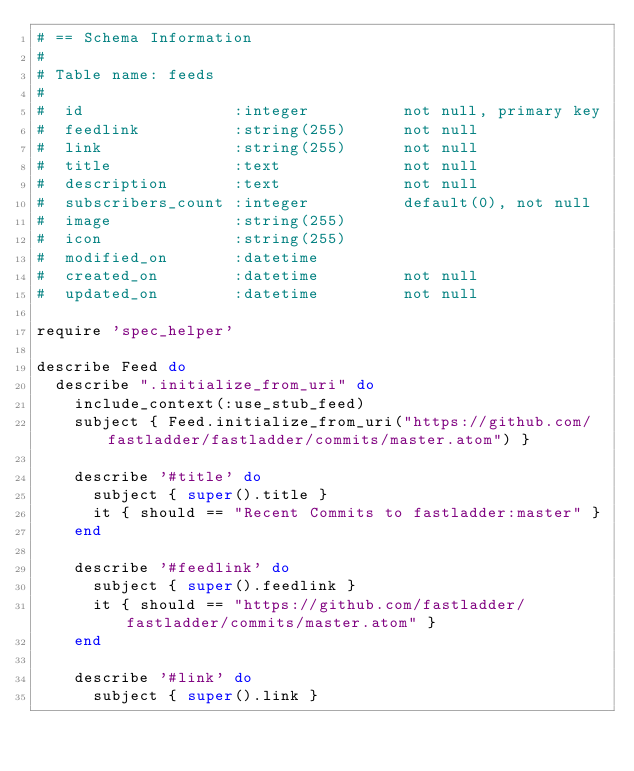<code> <loc_0><loc_0><loc_500><loc_500><_Ruby_># == Schema Information
#
# Table name: feeds
#
#  id                :integer          not null, primary key
#  feedlink          :string(255)      not null
#  link              :string(255)      not null
#  title             :text             not null
#  description       :text             not null
#  subscribers_count :integer          default(0), not null
#  image             :string(255)
#  icon              :string(255)
#  modified_on       :datetime
#  created_on        :datetime         not null
#  updated_on        :datetime         not null

require 'spec_helper'

describe Feed do
  describe ".initialize_from_uri" do
    include_context(:use_stub_feed)
    subject { Feed.initialize_from_uri("https://github.com/fastladder/fastladder/commits/master.atom") }

    describe '#title' do
      subject { super().title }
      it { should == "Recent Commits to fastladder:master" }
    end

    describe '#feedlink' do
      subject { super().feedlink }
      it { should == "https://github.com/fastladder/fastladder/commits/master.atom" }
    end

    describe '#link' do
      subject { super().link }</code> 